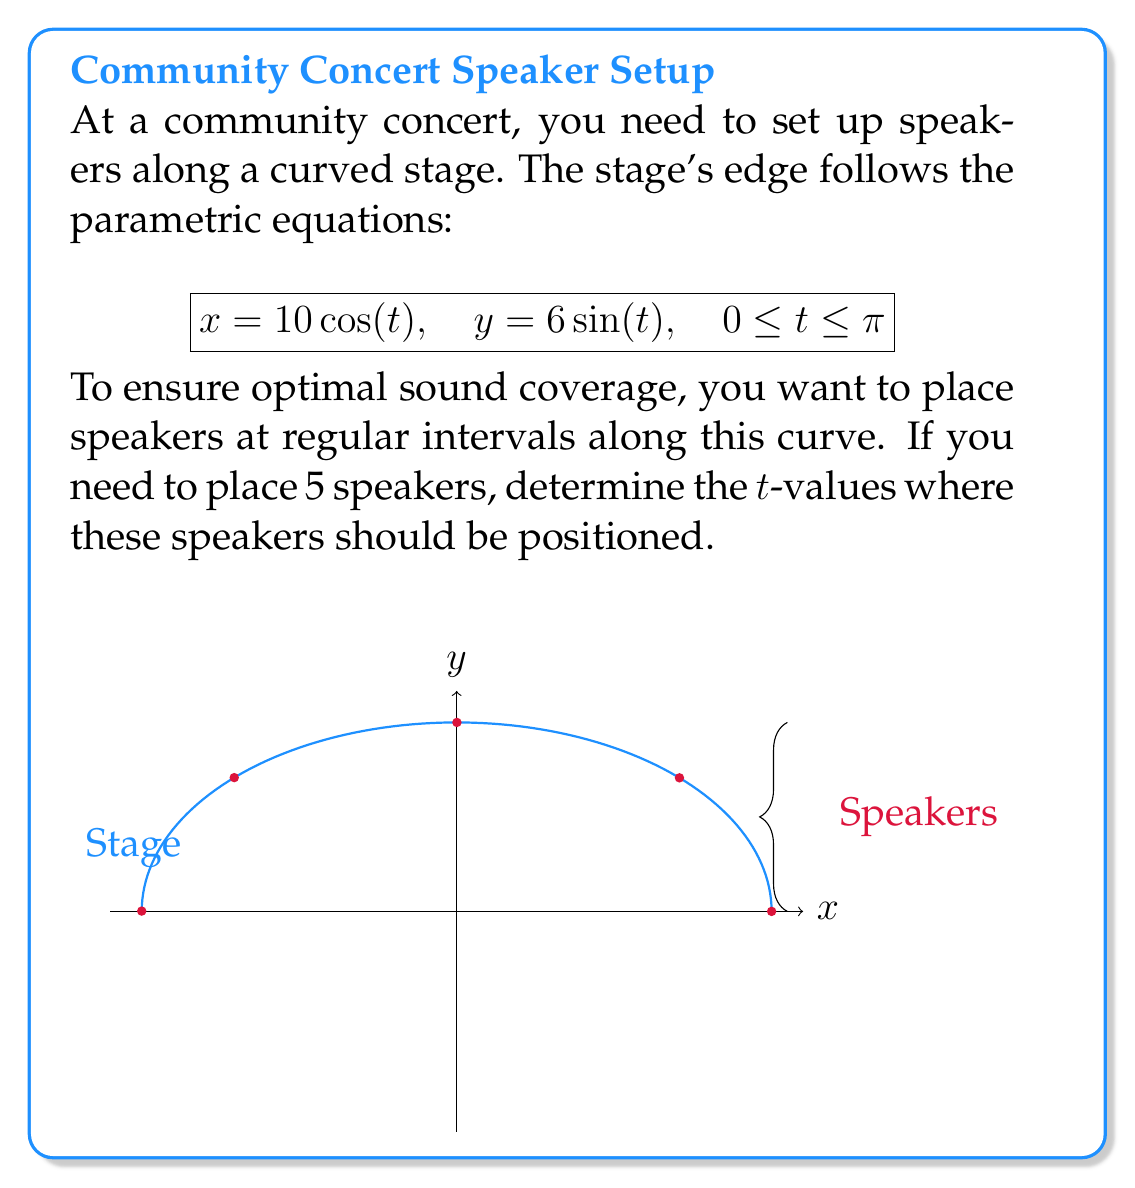Show me your answer to this math problem. To solve this problem, we'll follow these steps:

1) The curve represents half of an ellipse (from $t=0$ to $t=\pi$).

2) To place 5 speakers evenly, we need to divide the curve into 4 equal parts.

3) The total range of t is $\pi - 0 = \pi$.

4) To find the interval between speakers, divide the total range by the number of divisions:
   $$\text{Interval} = \frac{\pi}{4}$$

5) The t-values for the 5 speakers will be:
   - Speaker 1: $t_1 = 0$
   - Speaker 2: $t_2 = \frac{\pi}{4}$
   - Speaker 3: $t_3 = \frac{2\pi}{4} = \frac{\pi}{2}$
   - Speaker 4: $t_4 = \frac{3\pi}{4}$
   - Speaker 5: $t_5 = \pi$

6) These t-values ensure that the speakers are placed at equal arc length intervals along the curve.
Answer: $t = 0, \frac{\pi}{4}, \frac{\pi}{2}, \frac{3\pi}{4}, \pi$ 